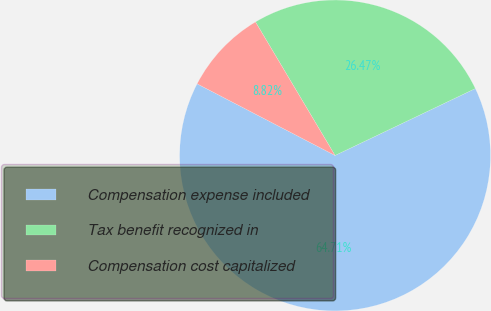Convert chart to OTSL. <chart><loc_0><loc_0><loc_500><loc_500><pie_chart><fcel>Compensation expense included<fcel>Tax benefit recognized in<fcel>Compensation cost capitalized<nl><fcel>64.71%<fcel>26.47%<fcel>8.82%<nl></chart> 